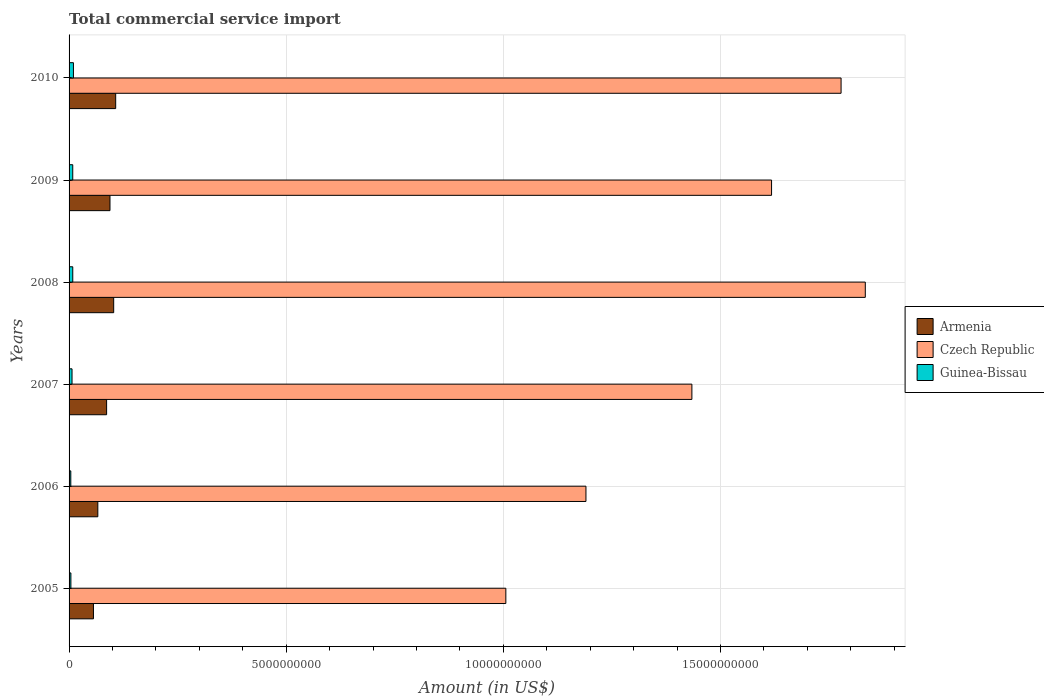Are the number of bars per tick equal to the number of legend labels?
Keep it short and to the point. Yes. Are the number of bars on each tick of the Y-axis equal?
Keep it short and to the point. Yes. What is the label of the 5th group of bars from the top?
Ensure brevity in your answer.  2006. What is the total commercial service import in Armenia in 2008?
Provide a short and direct response. 1.03e+09. Across all years, what is the maximum total commercial service import in Guinea-Bissau?
Your response must be concise. 1.01e+08. Across all years, what is the minimum total commercial service import in Guinea-Bissau?
Offer a terse response. 3.96e+07. In which year was the total commercial service import in Guinea-Bissau maximum?
Make the answer very short. 2010. What is the total total commercial service import in Czech Republic in the graph?
Provide a short and direct response. 8.86e+1. What is the difference between the total commercial service import in Guinea-Bissau in 2007 and that in 2009?
Make the answer very short. -1.63e+07. What is the difference between the total commercial service import in Czech Republic in 2010 and the total commercial service import in Guinea-Bissau in 2006?
Your answer should be compact. 1.77e+1. What is the average total commercial service import in Guinea-Bissau per year?
Ensure brevity in your answer.  7.00e+07. In the year 2005, what is the difference between the total commercial service import in Czech Republic and total commercial service import in Guinea-Bissau?
Your response must be concise. 1.00e+1. In how many years, is the total commercial service import in Czech Republic greater than 3000000000 US$?
Offer a very short reply. 6. What is the ratio of the total commercial service import in Czech Republic in 2007 to that in 2008?
Your response must be concise. 0.78. Is the difference between the total commercial service import in Czech Republic in 2008 and 2009 greater than the difference between the total commercial service import in Guinea-Bissau in 2008 and 2009?
Make the answer very short. Yes. What is the difference between the highest and the second highest total commercial service import in Guinea-Bissau?
Provide a succinct answer. 1.53e+07. What is the difference between the highest and the lowest total commercial service import in Guinea-Bissau?
Provide a succinct answer. 6.09e+07. Is the sum of the total commercial service import in Guinea-Bissau in 2006 and 2008 greater than the maximum total commercial service import in Czech Republic across all years?
Provide a short and direct response. No. What does the 2nd bar from the top in 2009 represents?
Provide a short and direct response. Czech Republic. What does the 3rd bar from the bottom in 2008 represents?
Provide a succinct answer. Guinea-Bissau. How many bars are there?
Give a very brief answer. 18. Are all the bars in the graph horizontal?
Your response must be concise. Yes. How many years are there in the graph?
Keep it short and to the point. 6. Does the graph contain grids?
Your answer should be very brief. Yes. How many legend labels are there?
Make the answer very short. 3. What is the title of the graph?
Offer a terse response. Total commercial service import. Does "United Kingdom" appear as one of the legend labels in the graph?
Make the answer very short. No. What is the label or title of the X-axis?
Provide a short and direct response. Amount (in US$). What is the Amount (in US$) in Armenia in 2005?
Provide a succinct answer. 5.61e+08. What is the Amount (in US$) in Czech Republic in 2005?
Your answer should be very brief. 1.01e+1. What is the Amount (in US$) in Guinea-Bissau in 2005?
Your answer should be very brief. 4.17e+07. What is the Amount (in US$) of Armenia in 2006?
Make the answer very short. 6.62e+08. What is the Amount (in US$) of Czech Republic in 2006?
Provide a succinct answer. 1.19e+1. What is the Amount (in US$) of Guinea-Bissau in 2006?
Give a very brief answer. 3.96e+07. What is the Amount (in US$) of Armenia in 2007?
Offer a very short reply. 8.64e+08. What is the Amount (in US$) of Czech Republic in 2007?
Ensure brevity in your answer.  1.43e+1. What is the Amount (in US$) in Guinea-Bissau in 2007?
Your response must be concise. 6.82e+07. What is the Amount (in US$) in Armenia in 2008?
Your response must be concise. 1.03e+09. What is the Amount (in US$) of Czech Republic in 2008?
Your response must be concise. 1.83e+1. What is the Amount (in US$) in Guinea-Bissau in 2008?
Your answer should be compact. 8.52e+07. What is the Amount (in US$) in Armenia in 2009?
Your answer should be compact. 9.42e+08. What is the Amount (in US$) of Czech Republic in 2009?
Offer a terse response. 1.62e+1. What is the Amount (in US$) of Guinea-Bissau in 2009?
Your response must be concise. 8.46e+07. What is the Amount (in US$) in Armenia in 2010?
Provide a succinct answer. 1.07e+09. What is the Amount (in US$) of Czech Republic in 2010?
Make the answer very short. 1.78e+1. What is the Amount (in US$) in Guinea-Bissau in 2010?
Your answer should be compact. 1.01e+08. Across all years, what is the maximum Amount (in US$) in Armenia?
Offer a very short reply. 1.07e+09. Across all years, what is the maximum Amount (in US$) in Czech Republic?
Your answer should be very brief. 1.83e+1. Across all years, what is the maximum Amount (in US$) of Guinea-Bissau?
Ensure brevity in your answer.  1.01e+08. Across all years, what is the minimum Amount (in US$) of Armenia?
Provide a short and direct response. 5.61e+08. Across all years, what is the minimum Amount (in US$) of Czech Republic?
Provide a succinct answer. 1.01e+1. Across all years, what is the minimum Amount (in US$) of Guinea-Bissau?
Your answer should be compact. 3.96e+07. What is the total Amount (in US$) in Armenia in the graph?
Provide a succinct answer. 5.13e+09. What is the total Amount (in US$) in Czech Republic in the graph?
Give a very brief answer. 8.86e+1. What is the total Amount (in US$) in Guinea-Bissau in the graph?
Provide a short and direct response. 4.20e+08. What is the difference between the Amount (in US$) of Armenia in 2005 and that in 2006?
Your response must be concise. -1.01e+08. What is the difference between the Amount (in US$) in Czech Republic in 2005 and that in 2006?
Your answer should be compact. -1.84e+09. What is the difference between the Amount (in US$) of Guinea-Bissau in 2005 and that in 2006?
Give a very brief answer. 2.16e+06. What is the difference between the Amount (in US$) in Armenia in 2005 and that in 2007?
Keep it short and to the point. -3.03e+08. What is the difference between the Amount (in US$) in Czech Republic in 2005 and that in 2007?
Your response must be concise. -4.28e+09. What is the difference between the Amount (in US$) in Guinea-Bissau in 2005 and that in 2007?
Make the answer very short. -2.65e+07. What is the difference between the Amount (in US$) in Armenia in 2005 and that in 2008?
Provide a succinct answer. -4.66e+08. What is the difference between the Amount (in US$) in Czech Republic in 2005 and that in 2008?
Provide a succinct answer. -8.28e+09. What is the difference between the Amount (in US$) of Guinea-Bissau in 2005 and that in 2008?
Keep it short and to the point. -4.34e+07. What is the difference between the Amount (in US$) in Armenia in 2005 and that in 2009?
Ensure brevity in your answer.  -3.81e+08. What is the difference between the Amount (in US$) of Czech Republic in 2005 and that in 2009?
Offer a very short reply. -6.12e+09. What is the difference between the Amount (in US$) in Guinea-Bissau in 2005 and that in 2009?
Your answer should be compact. -4.28e+07. What is the difference between the Amount (in US$) in Armenia in 2005 and that in 2010?
Provide a short and direct response. -5.12e+08. What is the difference between the Amount (in US$) in Czech Republic in 2005 and that in 2010?
Provide a succinct answer. -7.72e+09. What is the difference between the Amount (in US$) in Guinea-Bissau in 2005 and that in 2010?
Keep it short and to the point. -5.88e+07. What is the difference between the Amount (in US$) of Armenia in 2006 and that in 2007?
Offer a terse response. -2.02e+08. What is the difference between the Amount (in US$) in Czech Republic in 2006 and that in 2007?
Keep it short and to the point. -2.44e+09. What is the difference between the Amount (in US$) in Guinea-Bissau in 2006 and that in 2007?
Your answer should be compact. -2.87e+07. What is the difference between the Amount (in US$) of Armenia in 2006 and that in 2008?
Your answer should be very brief. -3.65e+08. What is the difference between the Amount (in US$) of Czech Republic in 2006 and that in 2008?
Offer a very short reply. -6.43e+09. What is the difference between the Amount (in US$) in Guinea-Bissau in 2006 and that in 2008?
Provide a short and direct response. -4.56e+07. What is the difference between the Amount (in US$) of Armenia in 2006 and that in 2009?
Offer a terse response. -2.80e+08. What is the difference between the Amount (in US$) in Czech Republic in 2006 and that in 2009?
Offer a very short reply. -4.27e+09. What is the difference between the Amount (in US$) of Guinea-Bissau in 2006 and that in 2009?
Ensure brevity in your answer.  -4.50e+07. What is the difference between the Amount (in US$) in Armenia in 2006 and that in 2010?
Your answer should be very brief. -4.11e+08. What is the difference between the Amount (in US$) of Czech Republic in 2006 and that in 2010?
Provide a succinct answer. -5.87e+09. What is the difference between the Amount (in US$) of Guinea-Bissau in 2006 and that in 2010?
Your response must be concise. -6.09e+07. What is the difference between the Amount (in US$) of Armenia in 2007 and that in 2008?
Ensure brevity in your answer.  -1.63e+08. What is the difference between the Amount (in US$) of Czech Republic in 2007 and that in 2008?
Your answer should be compact. -3.99e+09. What is the difference between the Amount (in US$) in Guinea-Bissau in 2007 and that in 2008?
Give a very brief answer. -1.69e+07. What is the difference between the Amount (in US$) of Armenia in 2007 and that in 2009?
Offer a terse response. -7.76e+07. What is the difference between the Amount (in US$) of Czech Republic in 2007 and that in 2009?
Ensure brevity in your answer.  -1.83e+09. What is the difference between the Amount (in US$) of Guinea-Bissau in 2007 and that in 2009?
Your answer should be very brief. -1.63e+07. What is the difference between the Amount (in US$) in Armenia in 2007 and that in 2010?
Your answer should be very brief. -2.09e+08. What is the difference between the Amount (in US$) of Czech Republic in 2007 and that in 2010?
Offer a very short reply. -3.43e+09. What is the difference between the Amount (in US$) of Guinea-Bissau in 2007 and that in 2010?
Provide a short and direct response. -3.23e+07. What is the difference between the Amount (in US$) in Armenia in 2008 and that in 2009?
Your answer should be very brief. 8.54e+07. What is the difference between the Amount (in US$) of Czech Republic in 2008 and that in 2009?
Your answer should be compact. 2.16e+09. What is the difference between the Amount (in US$) in Guinea-Bissau in 2008 and that in 2009?
Your answer should be very brief. 6.30e+05. What is the difference between the Amount (in US$) in Armenia in 2008 and that in 2010?
Offer a terse response. -4.61e+07. What is the difference between the Amount (in US$) of Czech Republic in 2008 and that in 2010?
Your answer should be very brief. 5.58e+08. What is the difference between the Amount (in US$) in Guinea-Bissau in 2008 and that in 2010?
Your response must be concise. -1.53e+07. What is the difference between the Amount (in US$) in Armenia in 2009 and that in 2010?
Make the answer very short. -1.31e+08. What is the difference between the Amount (in US$) of Czech Republic in 2009 and that in 2010?
Your answer should be very brief. -1.60e+09. What is the difference between the Amount (in US$) of Guinea-Bissau in 2009 and that in 2010?
Your answer should be very brief. -1.59e+07. What is the difference between the Amount (in US$) of Armenia in 2005 and the Amount (in US$) of Czech Republic in 2006?
Offer a terse response. -1.13e+1. What is the difference between the Amount (in US$) of Armenia in 2005 and the Amount (in US$) of Guinea-Bissau in 2006?
Make the answer very short. 5.22e+08. What is the difference between the Amount (in US$) in Czech Republic in 2005 and the Amount (in US$) in Guinea-Bissau in 2006?
Ensure brevity in your answer.  1.00e+1. What is the difference between the Amount (in US$) of Armenia in 2005 and the Amount (in US$) of Czech Republic in 2007?
Your answer should be very brief. -1.38e+1. What is the difference between the Amount (in US$) in Armenia in 2005 and the Amount (in US$) in Guinea-Bissau in 2007?
Provide a succinct answer. 4.93e+08. What is the difference between the Amount (in US$) of Czech Republic in 2005 and the Amount (in US$) of Guinea-Bissau in 2007?
Offer a terse response. 9.99e+09. What is the difference between the Amount (in US$) in Armenia in 2005 and the Amount (in US$) in Czech Republic in 2008?
Provide a succinct answer. -1.78e+1. What is the difference between the Amount (in US$) in Armenia in 2005 and the Amount (in US$) in Guinea-Bissau in 2008?
Ensure brevity in your answer.  4.76e+08. What is the difference between the Amount (in US$) in Czech Republic in 2005 and the Amount (in US$) in Guinea-Bissau in 2008?
Your response must be concise. 9.97e+09. What is the difference between the Amount (in US$) in Armenia in 2005 and the Amount (in US$) in Czech Republic in 2009?
Provide a succinct answer. -1.56e+1. What is the difference between the Amount (in US$) of Armenia in 2005 and the Amount (in US$) of Guinea-Bissau in 2009?
Give a very brief answer. 4.77e+08. What is the difference between the Amount (in US$) of Czech Republic in 2005 and the Amount (in US$) of Guinea-Bissau in 2009?
Offer a terse response. 9.97e+09. What is the difference between the Amount (in US$) of Armenia in 2005 and the Amount (in US$) of Czech Republic in 2010?
Make the answer very short. -1.72e+1. What is the difference between the Amount (in US$) in Armenia in 2005 and the Amount (in US$) in Guinea-Bissau in 2010?
Your response must be concise. 4.61e+08. What is the difference between the Amount (in US$) in Czech Republic in 2005 and the Amount (in US$) in Guinea-Bissau in 2010?
Offer a terse response. 9.96e+09. What is the difference between the Amount (in US$) of Armenia in 2006 and the Amount (in US$) of Czech Republic in 2007?
Give a very brief answer. -1.37e+1. What is the difference between the Amount (in US$) of Armenia in 2006 and the Amount (in US$) of Guinea-Bissau in 2007?
Your answer should be very brief. 5.94e+08. What is the difference between the Amount (in US$) in Czech Republic in 2006 and the Amount (in US$) in Guinea-Bissau in 2007?
Provide a short and direct response. 1.18e+1. What is the difference between the Amount (in US$) of Armenia in 2006 and the Amount (in US$) of Czech Republic in 2008?
Provide a succinct answer. -1.77e+1. What is the difference between the Amount (in US$) of Armenia in 2006 and the Amount (in US$) of Guinea-Bissau in 2008?
Your answer should be compact. 5.77e+08. What is the difference between the Amount (in US$) in Czech Republic in 2006 and the Amount (in US$) in Guinea-Bissau in 2008?
Your answer should be compact. 1.18e+1. What is the difference between the Amount (in US$) of Armenia in 2006 and the Amount (in US$) of Czech Republic in 2009?
Your answer should be very brief. -1.55e+1. What is the difference between the Amount (in US$) of Armenia in 2006 and the Amount (in US$) of Guinea-Bissau in 2009?
Your answer should be compact. 5.78e+08. What is the difference between the Amount (in US$) in Czech Republic in 2006 and the Amount (in US$) in Guinea-Bissau in 2009?
Your answer should be very brief. 1.18e+1. What is the difference between the Amount (in US$) in Armenia in 2006 and the Amount (in US$) in Czech Republic in 2010?
Your answer should be very brief. -1.71e+1. What is the difference between the Amount (in US$) in Armenia in 2006 and the Amount (in US$) in Guinea-Bissau in 2010?
Keep it short and to the point. 5.62e+08. What is the difference between the Amount (in US$) of Czech Republic in 2006 and the Amount (in US$) of Guinea-Bissau in 2010?
Give a very brief answer. 1.18e+1. What is the difference between the Amount (in US$) in Armenia in 2007 and the Amount (in US$) in Czech Republic in 2008?
Provide a succinct answer. -1.75e+1. What is the difference between the Amount (in US$) of Armenia in 2007 and the Amount (in US$) of Guinea-Bissau in 2008?
Keep it short and to the point. 7.79e+08. What is the difference between the Amount (in US$) of Czech Republic in 2007 and the Amount (in US$) of Guinea-Bissau in 2008?
Make the answer very short. 1.43e+1. What is the difference between the Amount (in US$) of Armenia in 2007 and the Amount (in US$) of Czech Republic in 2009?
Your answer should be compact. -1.53e+1. What is the difference between the Amount (in US$) of Armenia in 2007 and the Amount (in US$) of Guinea-Bissau in 2009?
Your answer should be compact. 7.80e+08. What is the difference between the Amount (in US$) of Czech Republic in 2007 and the Amount (in US$) of Guinea-Bissau in 2009?
Your answer should be very brief. 1.43e+1. What is the difference between the Amount (in US$) in Armenia in 2007 and the Amount (in US$) in Czech Republic in 2010?
Provide a short and direct response. -1.69e+1. What is the difference between the Amount (in US$) in Armenia in 2007 and the Amount (in US$) in Guinea-Bissau in 2010?
Make the answer very short. 7.64e+08. What is the difference between the Amount (in US$) of Czech Republic in 2007 and the Amount (in US$) of Guinea-Bissau in 2010?
Give a very brief answer. 1.42e+1. What is the difference between the Amount (in US$) in Armenia in 2008 and the Amount (in US$) in Czech Republic in 2009?
Your answer should be very brief. -1.51e+1. What is the difference between the Amount (in US$) in Armenia in 2008 and the Amount (in US$) in Guinea-Bissau in 2009?
Make the answer very short. 9.43e+08. What is the difference between the Amount (in US$) in Czech Republic in 2008 and the Amount (in US$) in Guinea-Bissau in 2009?
Provide a succinct answer. 1.82e+1. What is the difference between the Amount (in US$) of Armenia in 2008 and the Amount (in US$) of Czech Republic in 2010?
Offer a terse response. -1.67e+1. What is the difference between the Amount (in US$) in Armenia in 2008 and the Amount (in US$) in Guinea-Bissau in 2010?
Offer a terse response. 9.27e+08. What is the difference between the Amount (in US$) in Czech Republic in 2008 and the Amount (in US$) in Guinea-Bissau in 2010?
Offer a very short reply. 1.82e+1. What is the difference between the Amount (in US$) in Armenia in 2009 and the Amount (in US$) in Czech Republic in 2010?
Offer a very short reply. -1.68e+1. What is the difference between the Amount (in US$) of Armenia in 2009 and the Amount (in US$) of Guinea-Bissau in 2010?
Make the answer very short. 8.42e+08. What is the difference between the Amount (in US$) in Czech Republic in 2009 and the Amount (in US$) in Guinea-Bissau in 2010?
Your answer should be very brief. 1.61e+1. What is the average Amount (in US$) in Armenia per year?
Offer a terse response. 8.55e+08. What is the average Amount (in US$) of Czech Republic per year?
Keep it short and to the point. 1.48e+1. What is the average Amount (in US$) of Guinea-Bissau per year?
Your response must be concise. 7.00e+07. In the year 2005, what is the difference between the Amount (in US$) of Armenia and Amount (in US$) of Czech Republic?
Make the answer very short. -9.50e+09. In the year 2005, what is the difference between the Amount (in US$) of Armenia and Amount (in US$) of Guinea-Bissau?
Offer a terse response. 5.20e+08. In the year 2005, what is the difference between the Amount (in US$) in Czech Republic and Amount (in US$) in Guinea-Bissau?
Your response must be concise. 1.00e+1. In the year 2006, what is the difference between the Amount (in US$) in Armenia and Amount (in US$) in Czech Republic?
Your answer should be compact. -1.12e+1. In the year 2006, what is the difference between the Amount (in US$) in Armenia and Amount (in US$) in Guinea-Bissau?
Offer a terse response. 6.23e+08. In the year 2006, what is the difference between the Amount (in US$) of Czech Republic and Amount (in US$) of Guinea-Bissau?
Make the answer very short. 1.19e+1. In the year 2007, what is the difference between the Amount (in US$) in Armenia and Amount (in US$) in Czech Republic?
Keep it short and to the point. -1.35e+1. In the year 2007, what is the difference between the Amount (in US$) of Armenia and Amount (in US$) of Guinea-Bissau?
Your answer should be compact. 7.96e+08. In the year 2007, what is the difference between the Amount (in US$) in Czech Republic and Amount (in US$) in Guinea-Bissau?
Keep it short and to the point. 1.43e+1. In the year 2008, what is the difference between the Amount (in US$) of Armenia and Amount (in US$) of Czech Republic?
Offer a very short reply. -1.73e+1. In the year 2008, what is the difference between the Amount (in US$) of Armenia and Amount (in US$) of Guinea-Bissau?
Ensure brevity in your answer.  9.42e+08. In the year 2008, what is the difference between the Amount (in US$) in Czech Republic and Amount (in US$) in Guinea-Bissau?
Your answer should be compact. 1.82e+1. In the year 2009, what is the difference between the Amount (in US$) of Armenia and Amount (in US$) of Czech Republic?
Your answer should be very brief. -1.52e+1. In the year 2009, what is the difference between the Amount (in US$) in Armenia and Amount (in US$) in Guinea-Bissau?
Provide a succinct answer. 8.57e+08. In the year 2009, what is the difference between the Amount (in US$) of Czech Republic and Amount (in US$) of Guinea-Bissau?
Offer a terse response. 1.61e+1. In the year 2010, what is the difference between the Amount (in US$) in Armenia and Amount (in US$) in Czech Republic?
Keep it short and to the point. -1.67e+1. In the year 2010, what is the difference between the Amount (in US$) in Armenia and Amount (in US$) in Guinea-Bissau?
Offer a terse response. 9.73e+08. In the year 2010, what is the difference between the Amount (in US$) in Czech Republic and Amount (in US$) in Guinea-Bissau?
Your answer should be very brief. 1.77e+1. What is the ratio of the Amount (in US$) of Armenia in 2005 to that in 2006?
Provide a succinct answer. 0.85. What is the ratio of the Amount (in US$) of Czech Republic in 2005 to that in 2006?
Provide a short and direct response. 0.84. What is the ratio of the Amount (in US$) in Guinea-Bissau in 2005 to that in 2006?
Your answer should be very brief. 1.05. What is the ratio of the Amount (in US$) in Armenia in 2005 to that in 2007?
Keep it short and to the point. 0.65. What is the ratio of the Amount (in US$) of Czech Republic in 2005 to that in 2007?
Keep it short and to the point. 0.7. What is the ratio of the Amount (in US$) in Guinea-Bissau in 2005 to that in 2007?
Your answer should be compact. 0.61. What is the ratio of the Amount (in US$) in Armenia in 2005 to that in 2008?
Your answer should be very brief. 0.55. What is the ratio of the Amount (in US$) in Czech Republic in 2005 to that in 2008?
Offer a very short reply. 0.55. What is the ratio of the Amount (in US$) of Guinea-Bissau in 2005 to that in 2008?
Ensure brevity in your answer.  0.49. What is the ratio of the Amount (in US$) in Armenia in 2005 to that in 2009?
Give a very brief answer. 0.6. What is the ratio of the Amount (in US$) in Czech Republic in 2005 to that in 2009?
Give a very brief answer. 0.62. What is the ratio of the Amount (in US$) in Guinea-Bissau in 2005 to that in 2009?
Give a very brief answer. 0.49. What is the ratio of the Amount (in US$) in Armenia in 2005 to that in 2010?
Offer a terse response. 0.52. What is the ratio of the Amount (in US$) of Czech Republic in 2005 to that in 2010?
Your answer should be compact. 0.57. What is the ratio of the Amount (in US$) in Guinea-Bissau in 2005 to that in 2010?
Your answer should be very brief. 0.42. What is the ratio of the Amount (in US$) of Armenia in 2006 to that in 2007?
Give a very brief answer. 0.77. What is the ratio of the Amount (in US$) in Czech Republic in 2006 to that in 2007?
Give a very brief answer. 0.83. What is the ratio of the Amount (in US$) in Guinea-Bissau in 2006 to that in 2007?
Give a very brief answer. 0.58. What is the ratio of the Amount (in US$) in Armenia in 2006 to that in 2008?
Provide a succinct answer. 0.64. What is the ratio of the Amount (in US$) of Czech Republic in 2006 to that in 2008?
Provide a succinct answer. 0.65. What is the ratio of the Amount (in US$) in Guinea-Bissau in 2006 to that in 2008?
Offer a terse response. 0.46. What is the ratio of the Amount (in US$) in Armenia in 2006 to that in 2009?
Ensure brevity in your answer.  0.7. What is the ratio of the Amount (in US$) of Czech Republic in 2006 to that in 2009?
Provide a short and direct response. 0.74. What is the ratio of the Amount (in US$) in Guinea-Bissau in 2006 to that in 2009?
Offer a terse response. 0.47. What is the ratio of the Amount (in US$) in Armenia in 2006 to that in 2010?
Your answer should be very brief. 0.62. What is the ratio of the Amount (in US$) in Czech Republic in 2006 to that in 2010?
Keep it short and to the point. 0.67. What is the ratio of the Amount (in US$) of Guinea-Bissau in 2006 to that in 2010?
Make the answer very short. 0.39. What is the ratio of the Amount (in US$) of Armenia in 2007 to that in 2008?
Offer a terse response. 0.84. What is the ratio of the Amount (in US$) of Czech Republic in 2007 to that in 2008?
Give a very brief answer. 0.78. What is the ratio of the Amount (in US$) of Guinea-Bissau in 2007 to that in 2008?
Make the answer very short. 0.8. What is the ratio of the Amount (in US$) in Armenia in 2007 to that in 2009?
Offer a very short reply. 0.92. What is the ratio of the Amount (in US$) in Czech Republic in 2007 to that in 2009?
Your response must be concise. 0.89. What is the ratio of the Amount (in US$) in Guinea-Bissau in 2007 to that in 2009?
Keep it short and to the point. 0.81. What is the ratio of the Amount (in US$) of Armenia in 2007 to that in 2010?
Offer a terse response. 0.81. What is the ratio of the Amount (in US$) in Czech Republic in 2007 to that in 2010?
Ensure brevity in your answer.  0.81. What is the ratio of the Amount (in US$) in Guinea-Bissau in 2007 to that in 2010?
Your response must be concise. 0.68. What is the ratio of the Amount (in US$) in Armenia in 2008 to that in 2009?
Give a very brief answer. 1.09. What is the ratio of the Amount (in US$) of Czech Republic in 2008 to that in 2009?
Make the answer very short. 1.13. What is the ratio of the Amount (in US$) in Guinea-Bissau in 2008 to that in 2009?
Keep it short and to the point. 1.01. What is the ratio of the Amount (in US$) of Armenia in 2008 to that in 2010?
Offer a terse response. 0.96. What is the ratio of the Amount (in US$) of Czech Republic in 2008 to that in 2010?
Give a very brief answer. 1.03. What is the ratio of the Amount (in US$) of Guinea-Bissau in 2008 to that in 2010?
Offer a very short reply. 0.85. What is the ratio of the Amount (in US$) in Armenia in 2009 to that in 2010?
Give a very brief answer. 0.88. What is the ratio of the Amount (in US$) in Czech Republic in 2009 to that in 2010?
Provide a short and direct response. 0.91. What is the ratio of the Amount (in US$) of Guinea-Bissau in 2009 to that in 2010?
Keep it short and to the point. 0.84. What is the difference between the highest and the second highest Amount (in US$) in Armenia?
Ensure brevity in your answer.  4.61e+07. What is the difference between the highest and the second highest Amount (in US$) of Czech Republic?
Keep it short and to the point. 5.58e+08. What is the difference between the highest and the second highest Amount (in US$) of Guinea-Bissau?
Offer a very short reply. 1.53e+07. What is the difference between the highest and the lowest Amount (in US$) of Armenia?
Your answer should be very brief. 5.12e+08. What is the difference between the highest and the lowest Amount (in US$) in Czech Republic?
Your answer should be very brief. 8.28e+09. What is the difference between the highest and the lowest Amount (in US$) of Guinea-Bissau?
Offer a very short reply. 6.09e+07. 